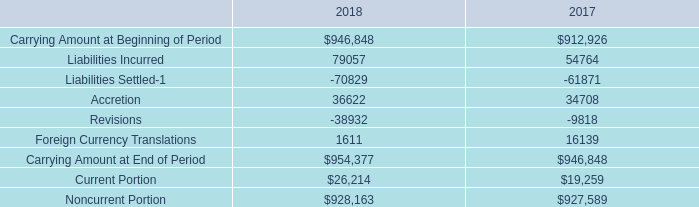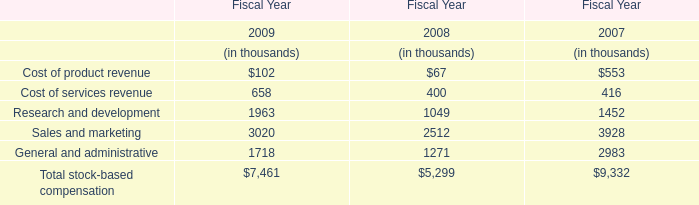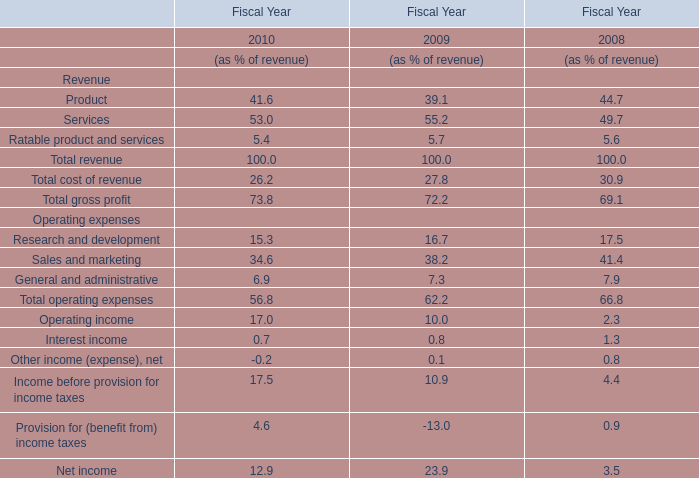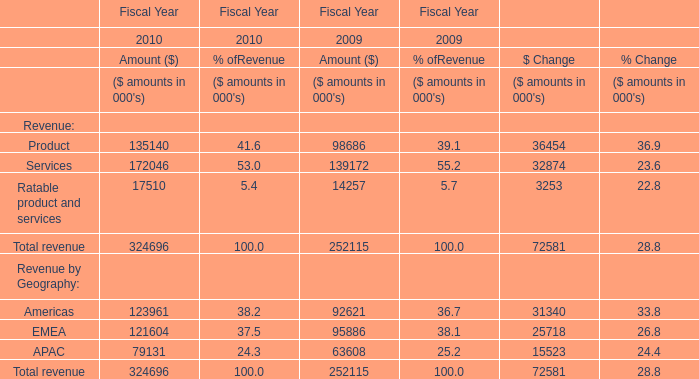When does Ratable product and services reach the largest value? 
Answer: 2010. 